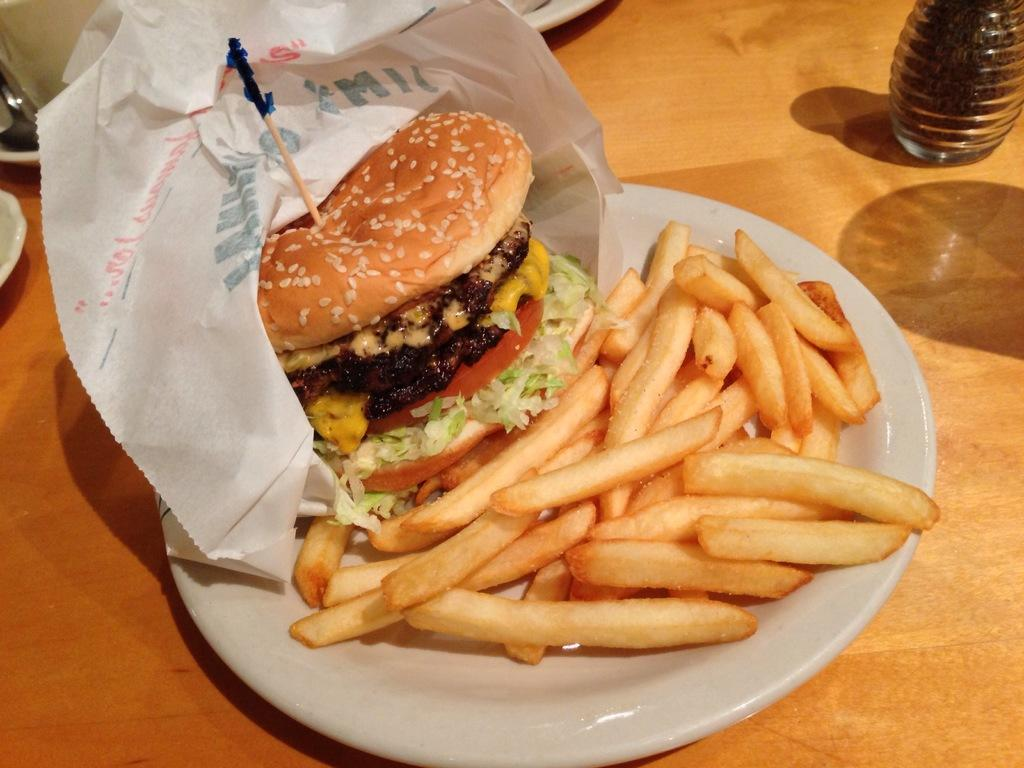What type of food is visible in the image? There is a burger in the image. What side dish is present with the burger? There are french fries in the image. Where are the burger and french fries placed? The burger and french fries are on a plate. On what surface is the plate located? The plate is on a table. What is the color of the table? The table is brown in color. How does the beggar interact with the burger and french fries in the image? There is no beggar present in the image; it only features a burger, french fries, a plate, and a table. What type of bike is visible in the image? There is no bike present in the image; it only features a burger, french fries, a plate, and a table. 